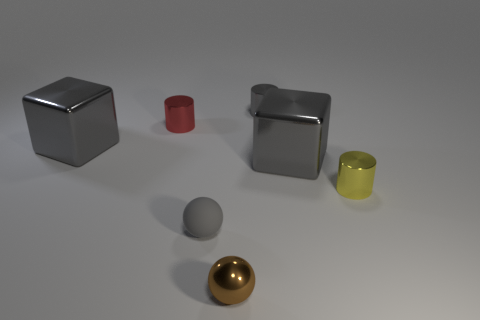Is there anything else that has the same material as the small gray sphere?
Give a very brief answer. No. There is a tiny red shiny object; what shape is it?
Make the answer very short. Cylinder. There is a matte object that is the same size as the brown sphere; what shape is it?
Ensure brevity in your answer.  Sphere. Are there any other things that have the same color as the tiny matte thing?
Your answer should be very brief. Yes. What is the size of the brown ball that is the same material as the red object?
Make the answer very short. Small. Is the shape of the red thing the same as the small gray metallic object that is behind the brown object?
Provide a succinct answer. Yes. Are there fewer tiny brown metallic things that are to the left of the brown shiny object than big metal objects?
Give a very brief answer. Yes. How many yellow objects are the same size as the rubber sphere?
Your answer should be very brief. 1. What is the shape of the small metal object that is the same color as the matte thing?
Your response must be concise. Cylinder. There is a large thing left of the small gray sphere; is it the same color as the big metallic cube right of the small gray metallic cylinder?
Provide a succinct answer. Yes. 